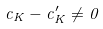Convert formula to latex. <formula><loc_0><loc_0><loc_500><loc_500>c _ { K } - c _ { K } ^ { \prime } \ne 0</formula> 